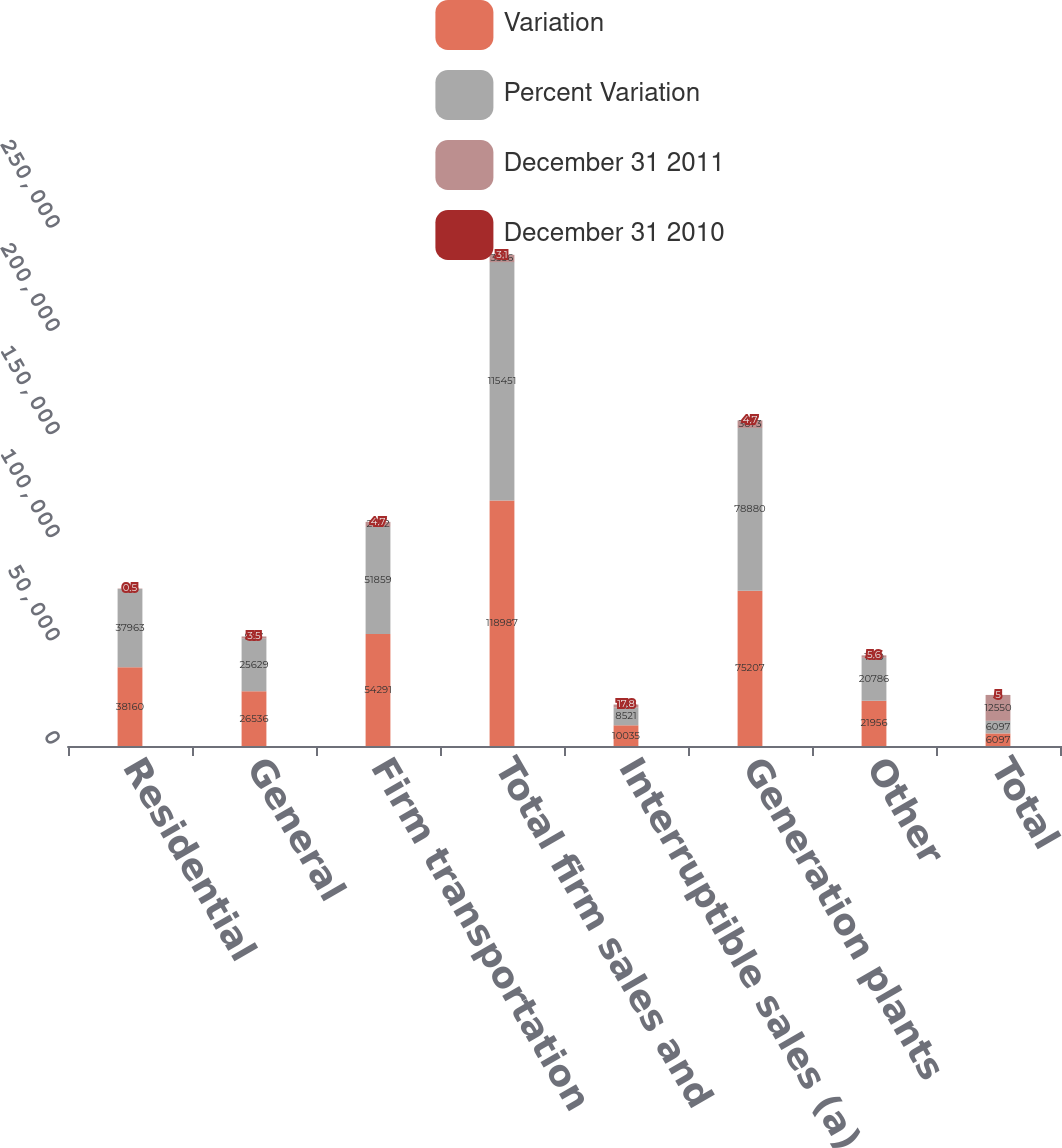<chart> <loc_0><loc_0><loc_500><loc_500><stacked_bar_chart><ecel><fcel>Residential<fcel>General<fcel>Firm transportation<fcel>Total firm sales and<fcel>Interruptible sales (a)<fcel>Generation plants<fcel>Other<fcel>Total<nl><fcel>Variation<fcel>38160<fcel>26536<fcel>54291<fcel>118987<fcel>10035<fcel>75207<fcel>21956<fcel>6097<nl><fcel>Percent Variation<fcel>37963<fcel>25629<fcel>51859<fcel>115451<fcel>8521<fcel>78880<fcel>20786<fcel>6097<nl><fcel>December 31 2011<fcel>197<fcel>907<fcel>2432<fcel>3536<fcel>1514<fcel>3673<fcel>1170<fcel>12550<nl><fcel>December 31 2010<fcel>0.5<fcel>3.5<fcel>4.7<fcel>3.1<fcel>17.8<fcel>4.7<fcel>5.6<fcel>5<nl></chart> 